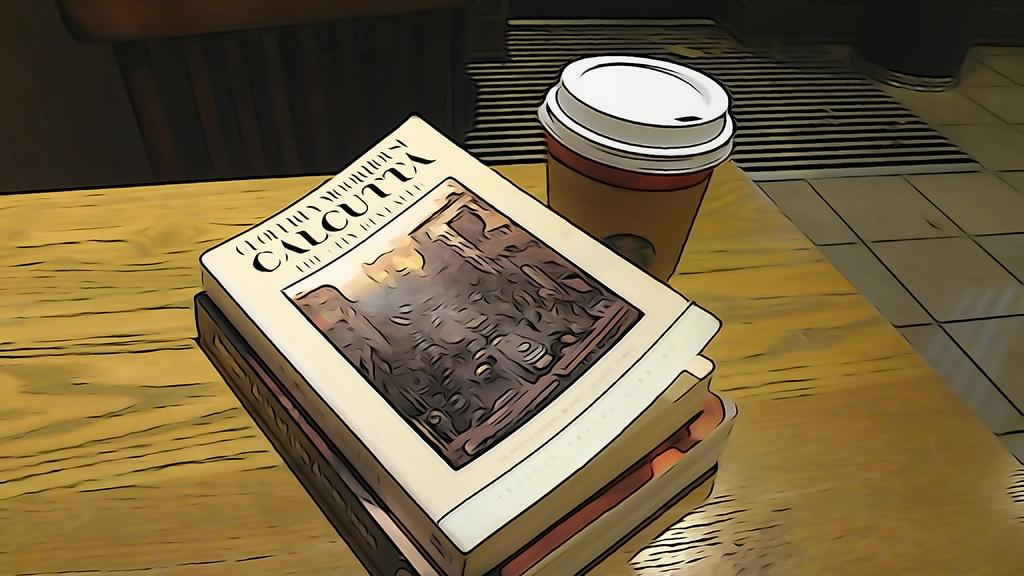<image>
Summarize the visual content of the image. A cartoon coffee and books, one is entitled Calcutta. 